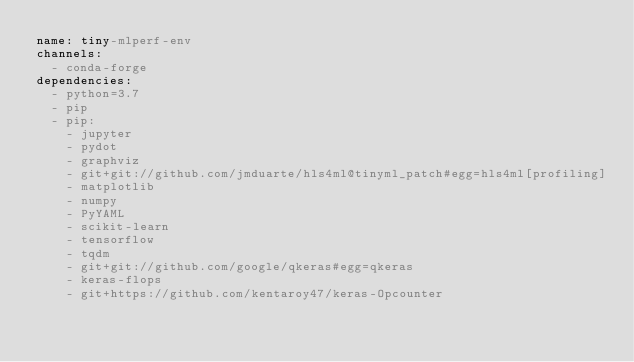Convert code to text. <code><loc_0><loc_0><loc_500><loc_500><_YAML_>name: tiny-mlperf-env
channels:
  - conda-forge
dependencies:
  - python=3.7
  - pip
  - pip:
    - jupyter
    - pydot
    - graphviz
    - git+git://github.com/jmduarte/hls4ml@tinyml_patch#egg=hls4ml[profiling]
    - matplotlib
    - numpy
    - PyYAML
    - scikit-learn
    - tensorflow
    - tqdm
    - git+git://github.com/google/qkeras#egg=qkeras
    - keras-flops
    - git+https://github.com/kentaroy47/keras-Opcounter
</code> 